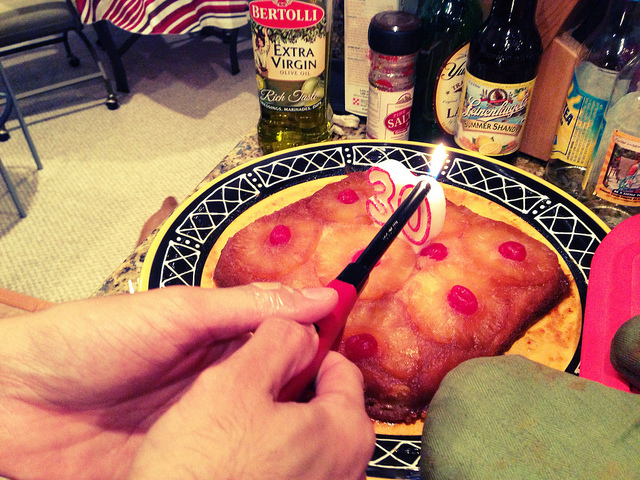Extract all visible text content from this image. BERTPLLI EXTRA VIRGIN Rich 30 